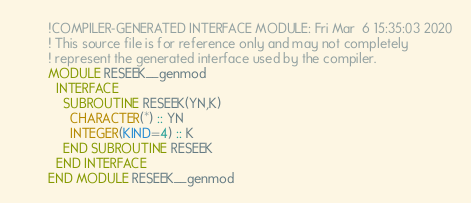<code> <loc_0><loc_0><loc_500><loc_500><_FORTRAN_>        !COMPILER-GENERATED INTERFACE MODULE: Fri Mar  6 15:35:03 2020
        ! This source file is for reference only and may not completely
        ! represent the generated interface used by the compiler.
        MODULE RESEEK__genmod
          INTERFACE 
            SUBROUTINE RESEEK(YN,K)
              CHARACTER(*) :: YN
              INTEGER(KIND=4) :: K
            END SUBROUTINE RESEEK
          END INTERFACE 
        END MODULE RESEEK__genmod
</code> 